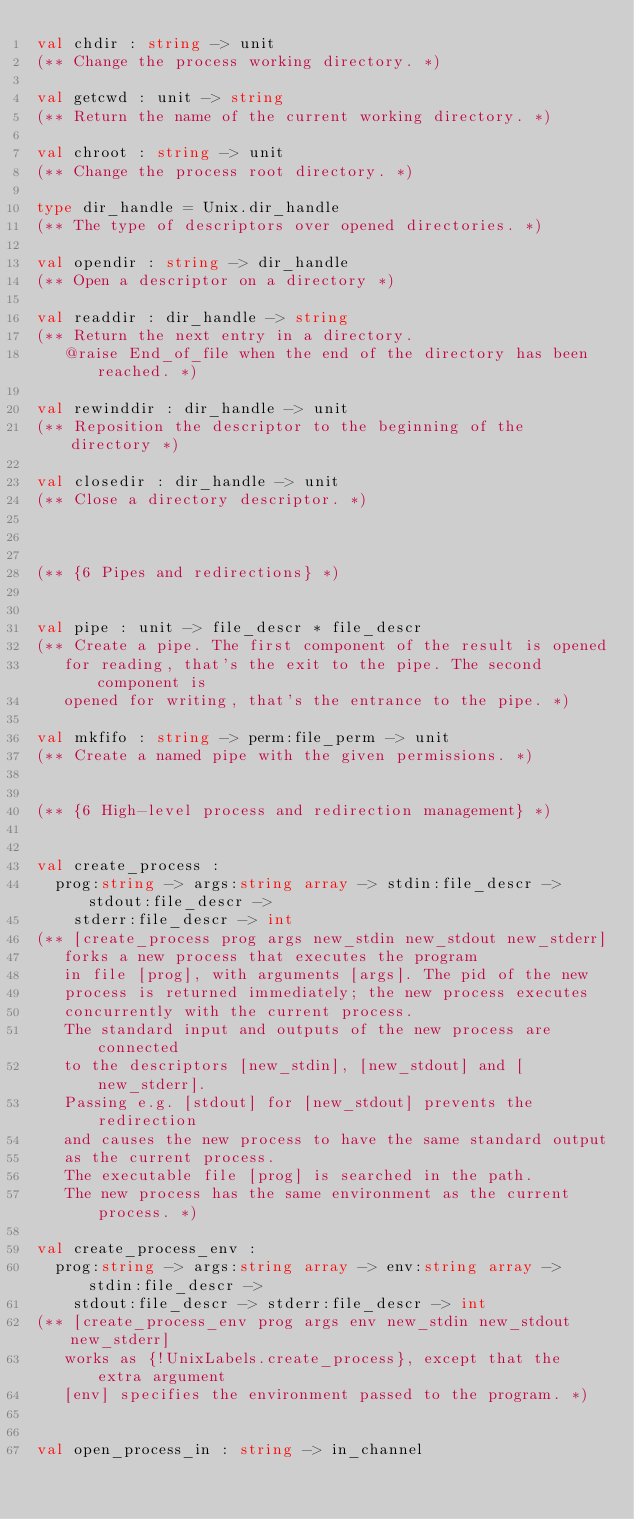<code> <loc_0><loc_0><loc_500><loc_500><_OCaml_>val chdir : string -> unit
(** Change the process working directory. *)

val getcwd : unit -> string
(** Return the name of the current working directory. *)

val chroot : string -> unit
(** Change the process root directory. *)

type dir_handle = Unix.dir_handle
(** The type of descriptors over opened directories. *)

val opendir : string -> dir_handle
(** Open a descriptor on a directory *)

val readdir : dir_handle -> string
(** Return the next entry in a directory.
   @raise End_of_file when the end of the directory has been reached. *)

val rewinddir : dir_handle -> unit
(** Reposition the descriptor to the beginning of the directory *)

val closedir : dir_handle -> unit
(** Close a directory descriptor. *)



(** {6 Pipes and redirections} *)


val pipe : unit -> file_descr * file_descr
(** Create a pipe. The first component of the result is opened
   for reading, that's the exit to the pipe. The second component is
   opened for writing, that's the entrance to the pipe. *)

val mkfifo : string -> perm:file_perm -> unit
(** Create a named pipe with the given permissions. *)


(** {6 High-level process and redirection management} *)


val create_process :
  prog:string -> args:string array -> stdin:file_descr -> stdout:file_descr ->
    stderr:file_descr -> int
(** [create_process prog args new_stdin new_stdout new_stderr]
   forks a new process that executes the program
   in file [prog], with arguments [args]. The pid of the new
   process is returned immediately; the new process executes
   concurrently with the current process.
   The standard input and outputs of the new process are connected
   to the descriptors [new_stdin], [new_stdout] and [new_stderr].
   Passing e.g. [stdout] for [new_stdout] prevents the redirection
   and causes the new process to have the same standard output
   as the current process.
   The executable file [prog] is searched in the path.
   The new process has the same environment as the current process. *)

val create_process_env :
  prog:string -> args:string array -> env:string array -> stdin:file_descr ->
    stdout:file_descr -> stderr:file_descr -> int
(** [create_process_env prog args env new_stdin new_stdout new_stderr]
   works as {!UnixLabels.create_process}, except that the extra argument
   [env] specifies the environment passed to the program. *)


val open_process_in : string -> in_channel</code> 